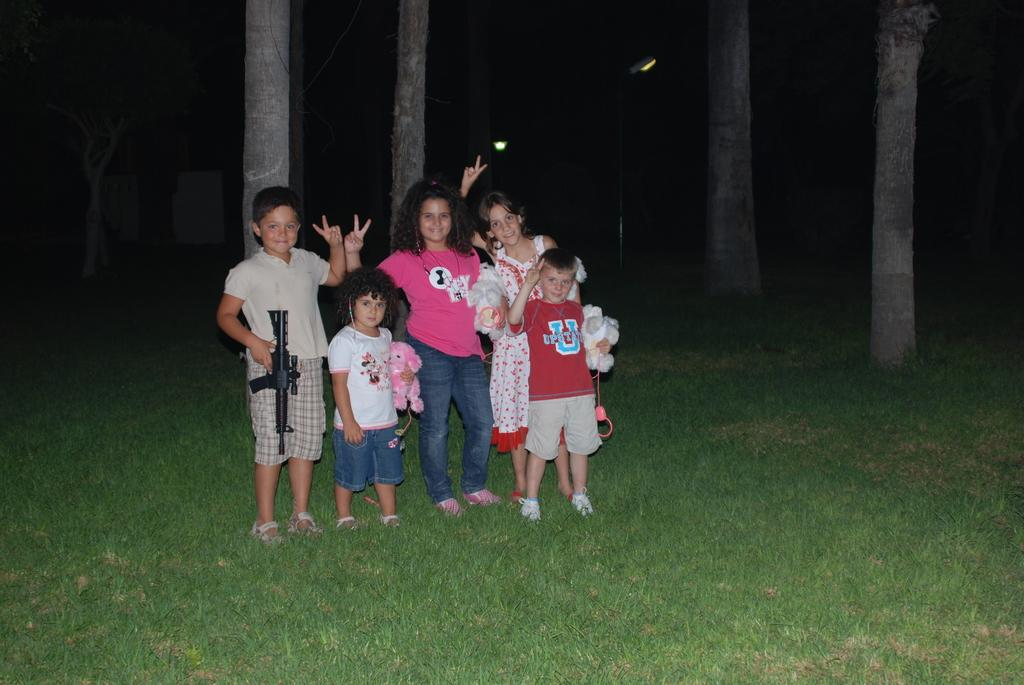What can be seen in the image? There are children in the image. What are the children holding? The children are holding toys. What is the ground covered with? The land is covered with grass. How would you describe the background of the image? The background of the image is dark. What structures are present in the image? There are light poles in the image. What type of vegetation is visible in the image? There are trees in the image. What type of fork is being used by the children in the image? There is no fork present in the image; the children are holding toys. How many friends are visible in the image? There is no mention of friends in the image; only children are present. 